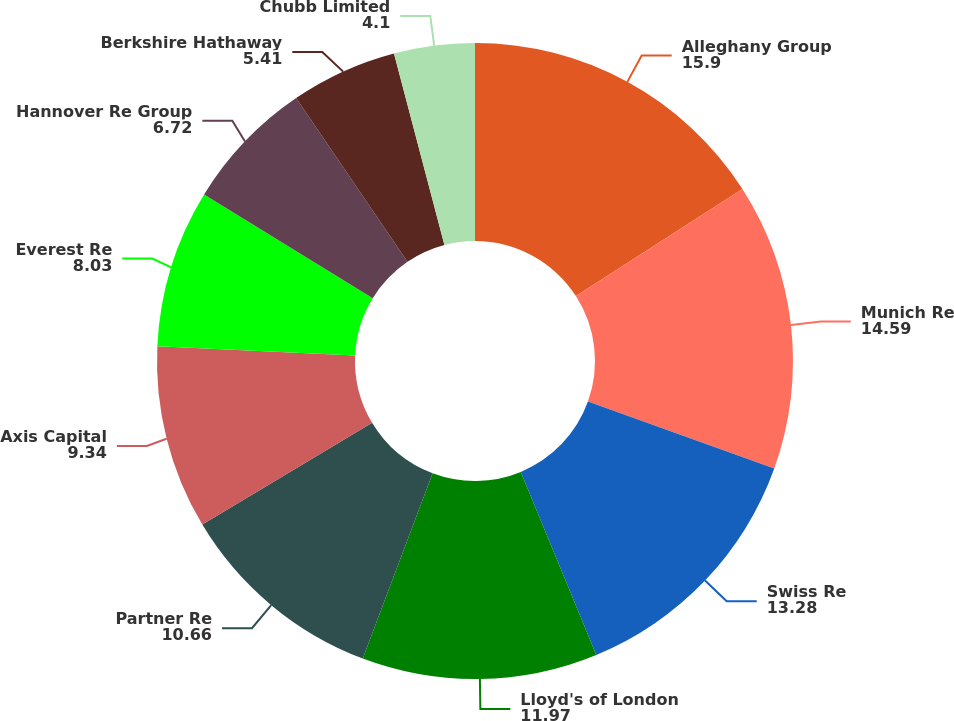<chart> <loc_0><loc_0><loc_500><loc_500><pie_chart><fcel>Alleghany Group<fcel>Munich Re<fcel>Swiss Re<fcel>Lloyd's of London<fcel>Partner Re<fcel>Axis Capital<fcel>Everest Re<fcel>Hannover Re Group<fcel>Berkshire Hathaway<fcel>Chubb Limited<nl><fcel>15.9%<fcel>14.59%<fcel>13.28%<fcel>11.97%<fcel>10.66%<fcel>9.34%<fcel>8.03%<fcel>6.72%<fcel>5.41%<fcel>4.1%<nl></chart> 